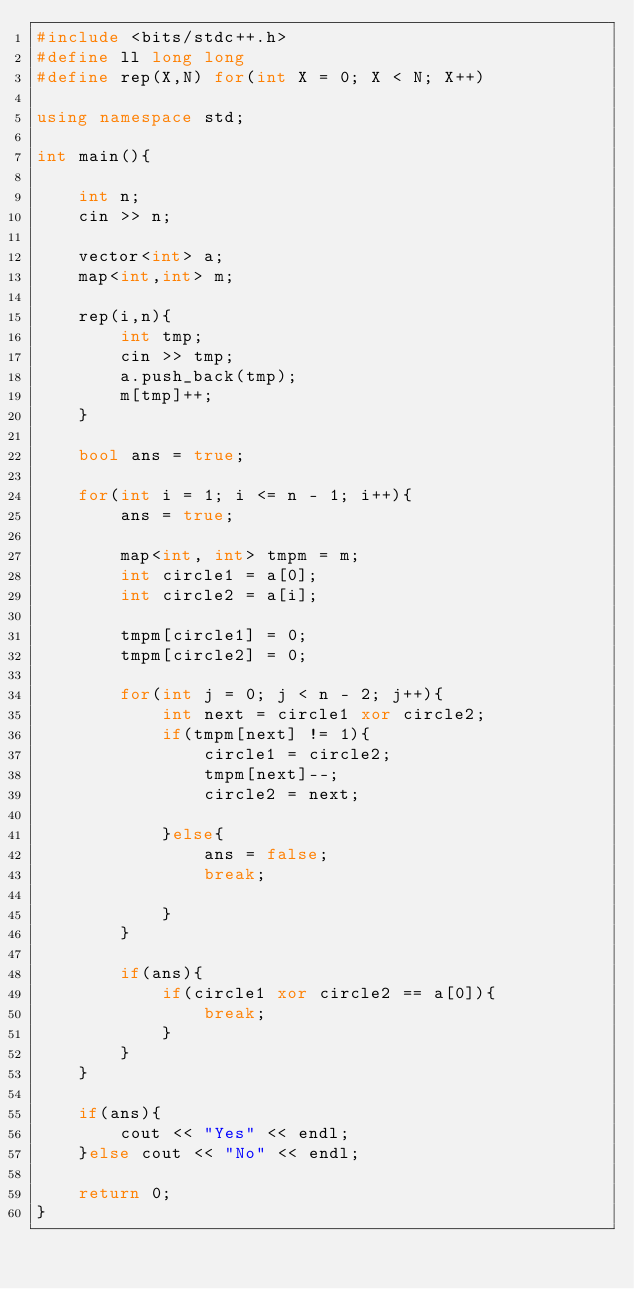Convert code to text. <code><loc_0><loc_0><loc_500><loc_500><_C++_>#include <bits/stdc++.h>
#define ll long long
#define rep(X,N) for(int X = 0; X < N; X++)

using namespace std;

int main(){

    int n;
    cin >> n;

    vector<int> a;
    map<int,int> m;

    rep(i,n){
        int tmp;
        cin >> tmp;
        a.push_back(tmp);
        m[tmp]++;
    }

    bool ans = true;

    for(int i = 1; i <= n - 1; i++){
        ans = true;

        map<int, int> tmpm = m;
        int circle1 = a[0];
        int circle2 = a[i];

        tmpm[circle1] = 0;
        tmpm[circle2] = 0;

        for(int j = 0; j < n - 2; j++){
            int next = circle1 xor circle2;
            if(tmpm[next] != 1){
                circle1 = circle2;
                tmpm[next]--;
                circle2 = next;

            }else{
                ans = false;
                break;

            }
        }

        if(ans){
            if(circle1 xor circle2 == a[0]){
                break;
            }
        }
    }

    if(ans){
        cout << "Yes" << endl;
    }else cout << "No" << endl;
    
    return 0;
}</code> 